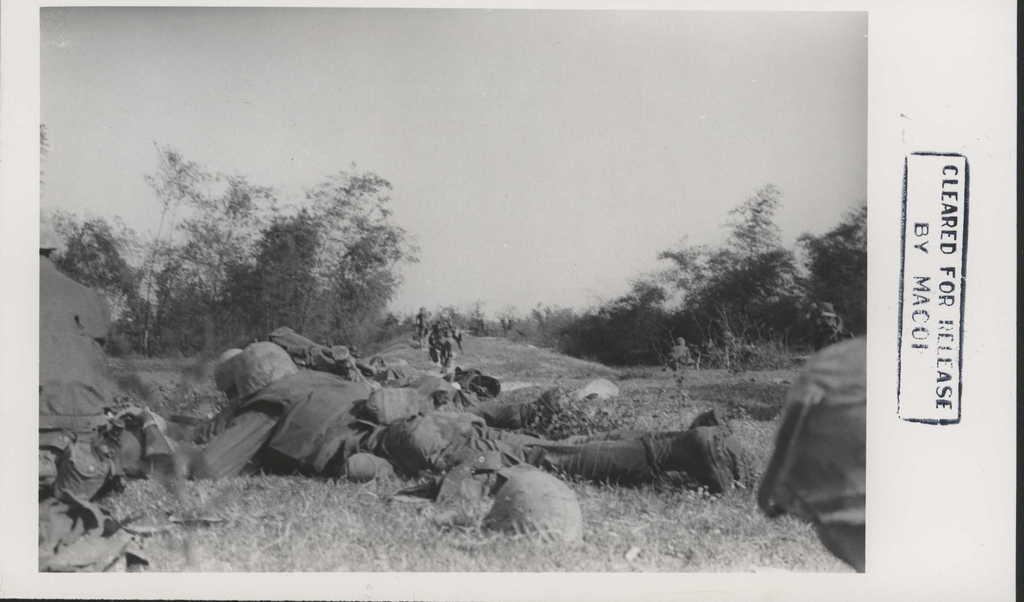How would you summarize this image in a sentence or two? In this picture I can observe some soldiers lying on the ground. In the background there are trees and sky. On the right side I can observe some text. 